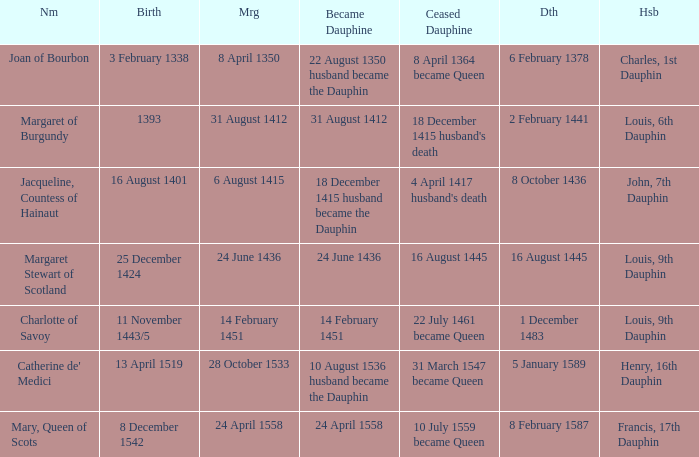When was the death of the person with husband charles, 1st dauphin? 6 February 1378. 